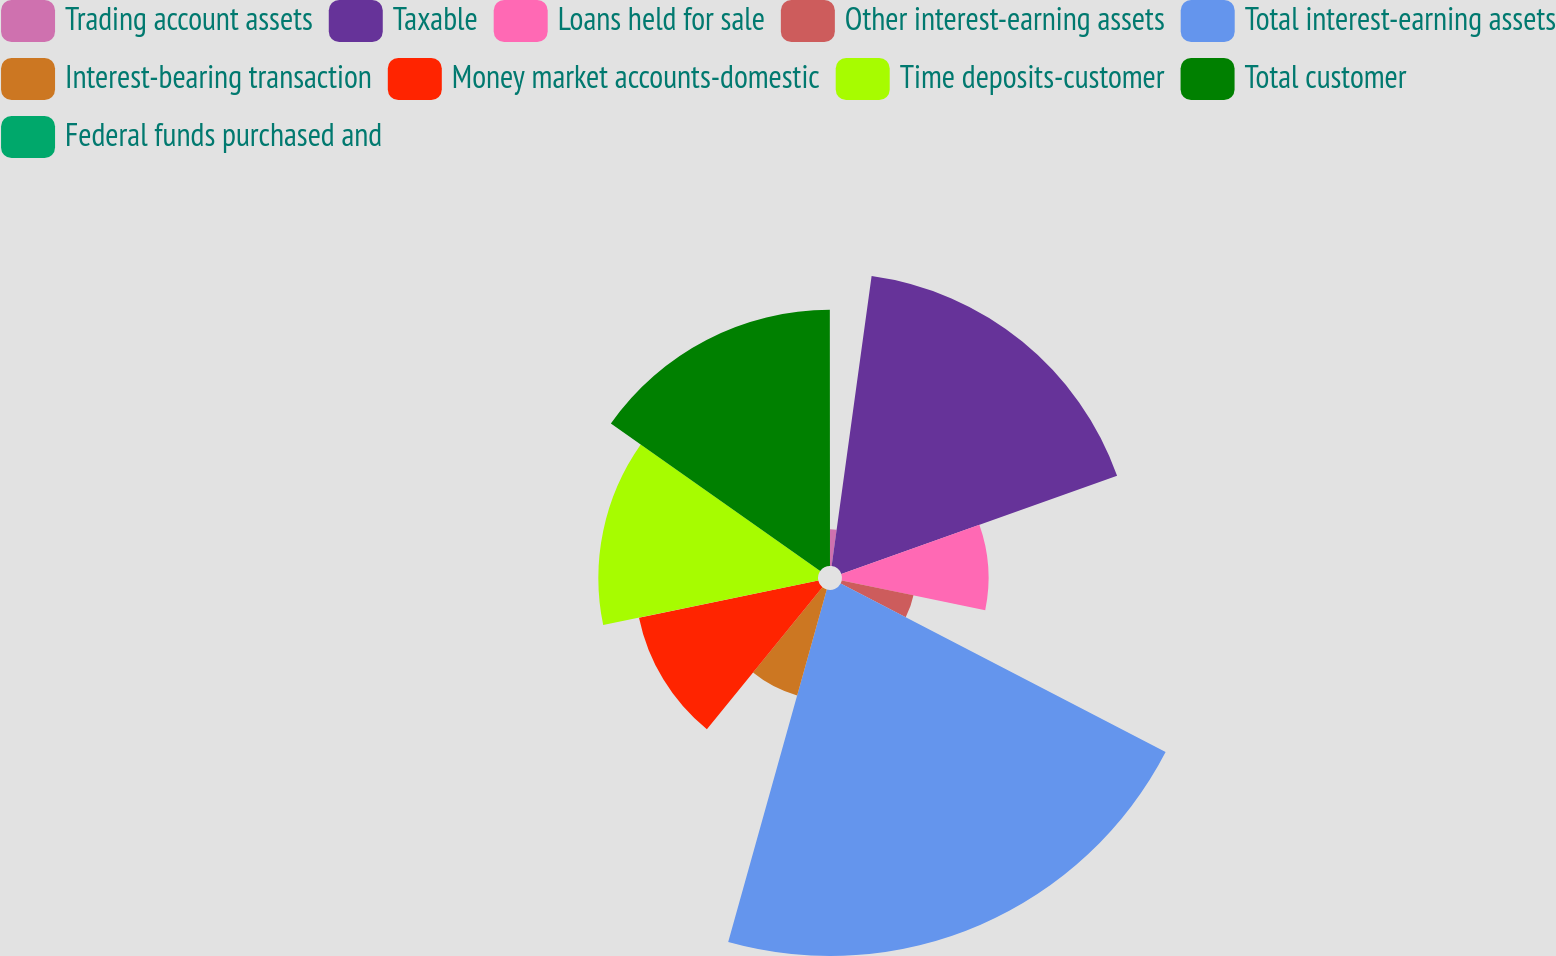Convert chart to OTSL. <chart><loc_0><loc_0><loc_500><loc_500><pie_chart><fcel>Trading account assets<fcel>Taxable<fcel>Loans held for sale<fcel>Other interest-earning assets<fcel>Total interest-earning assets<fcel>Interest-bearing transaction<fcel>Money market accounts-domestic<fcel>Time deposits-customer<fcel>Total customer<fcel>Federal funds purchased and<nl><fcel>2.18%<fcel>17.38%<fcel>8.7%<fcel>4.35%<fcel>21.73%<fcel>6.53%<fcel>10.87%<fcel>13.04%<fcel>15.21%<fcel>0.01%<nl></chart> 